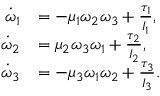<formula> <loc_0><loc_0><loc_500><loc_500>\begin{array} { r l } { \dot { \omega } _ { 1 } } & { = - \mu _ { 1 } \omega _ { 2 } \omega _ { 3 } + \frac { \tau _ { 1 } } { I _ { 1 } } , } \\ { \dot { \omega } _ { 2 } } & { = \mu _ { 2 } \omega _ { 3 } \omega _ { 1 } + \frac { \tau _ { 2 } } { I _ { 2 } } , } \\ { \dot { \omega } _ { 3 } } & { = - \mu _ { 3 } \omega _ { 1 } \omega _ { 2 } + \frac { \tau _ { 3 } } { I _ { 3 } } . } \end{array}</formula> 